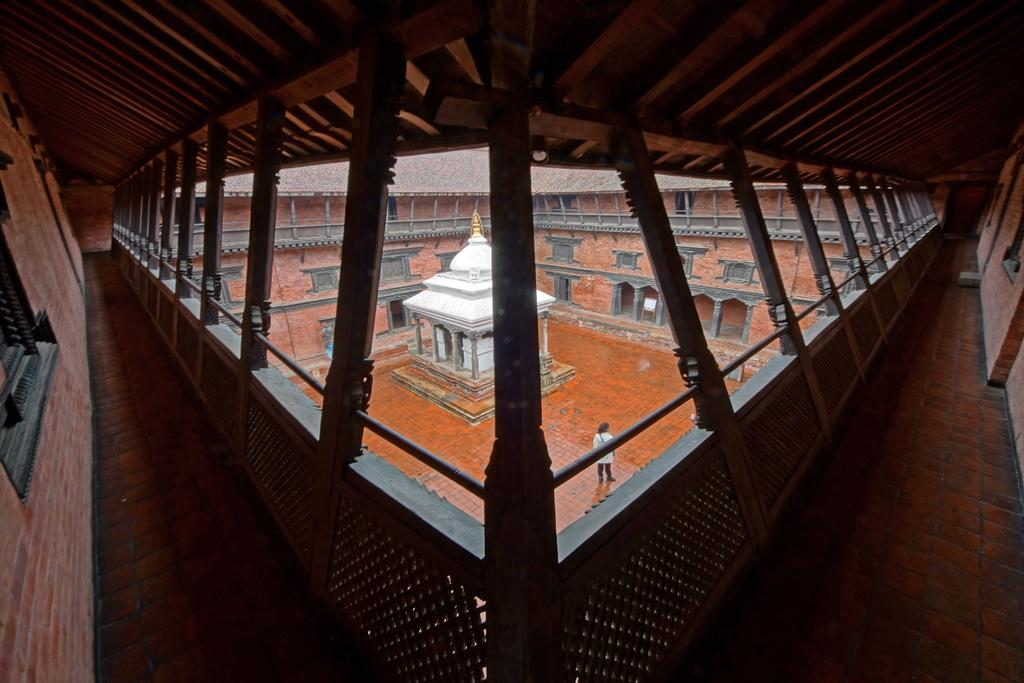What type of view is shown in the image? The image shows an inner view of a building. What structure is visible on the ground in the image? There is a house on the ground in the image. Can you describe the person in the image? A person is standing in the image. What type of barrier is present in the image? There is a fence in the image. What are the vertical supports in the image? There are poles in the image. What allows light and air to enter the building in the image? There are windows in the image. What other objects can be seen in the image? There are other objects visible in the image. What type of honey is being collected by the porter in the image? There is no porter or honey present in the image. 